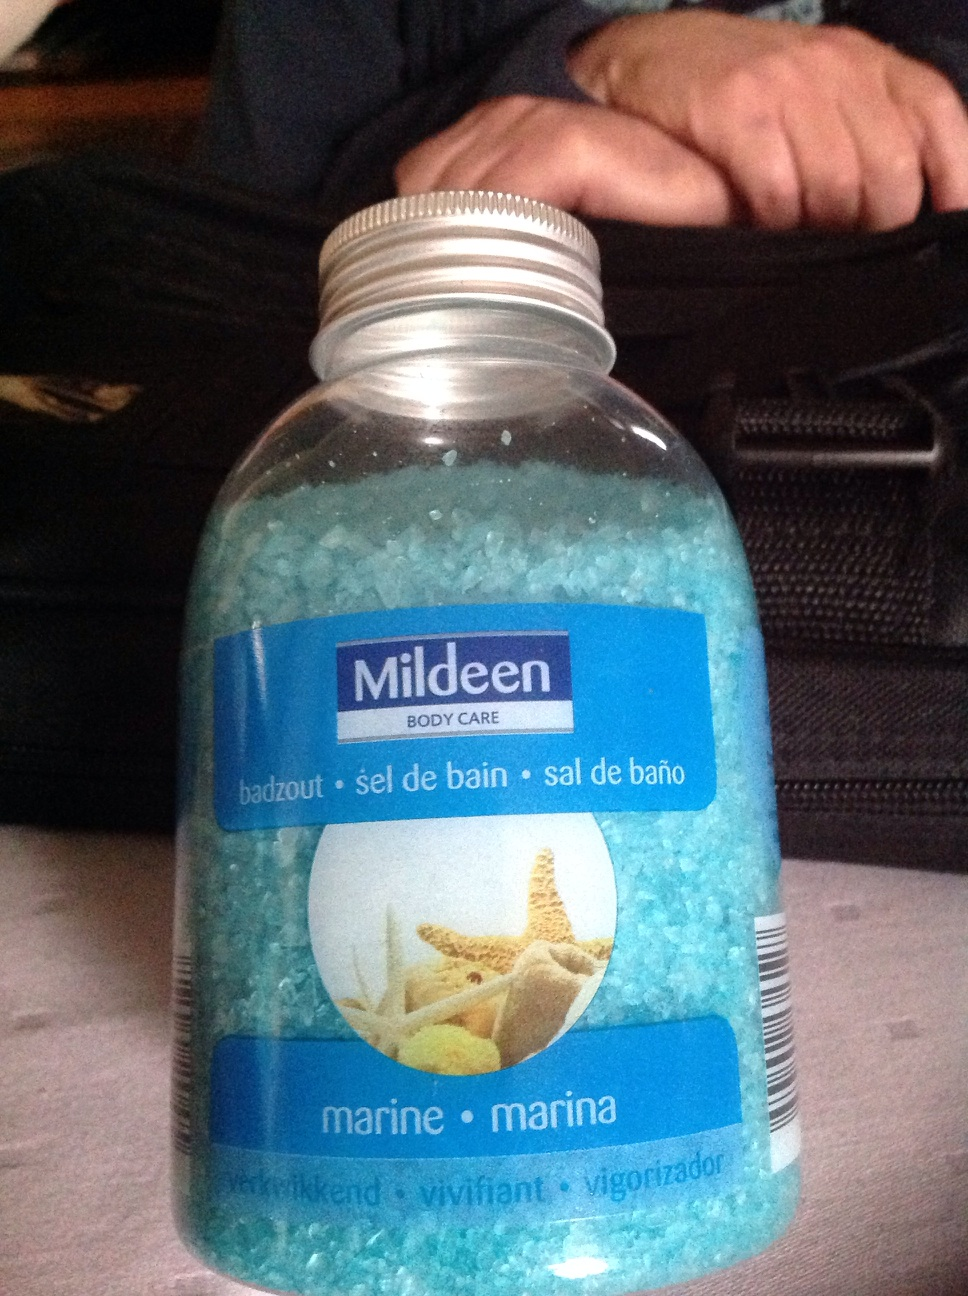How should this product be used for maximum benefit? For maximum benefits, dissolve a generous amount of the bath salts in warm bath water. Soak in the bath for at least 20 minutes to allow the minerals and essential oils to work effectively on relaxing muscles and hydrating the skin. 